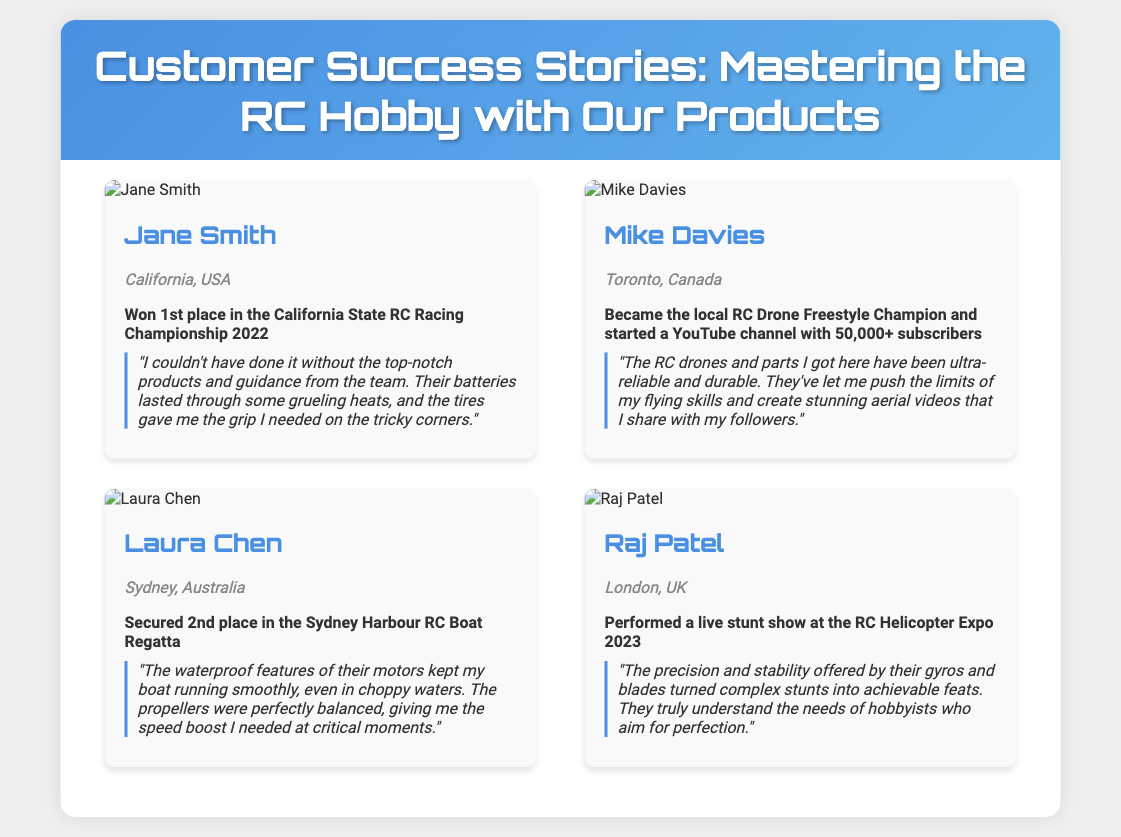What was Jane Smith's achievement in 2022? Jane Smith won 1st place in the California State RC Racing Championship in 2022.
Answer: 1st place in the California State RC Racing Championship 2022 Where is Mike Davies located? Mike Davies is based in Toronto, Canada.
Answer: Toronto, Canada How many subscribers does Mike Davies' YouTube channel have? Mike Davies has 50,000+ subscribers on his YouTube channel.
Answer: 50,000+ What feature of Laura Chen's motors helped in choppy waters? The waterproof features of Laura Chen's motors kept her boat running smoothly even in choppy waters.
Answer: Waterproof features What was Raj Patel's notable achievement in 2023? Raj Patel performed a live stunt show at the RC Helicopter Expo 2023.
Answer: Live stunt show at the RC Helicopter Expo 2023 What specific parts does Mike Davies appreciate for their reliability? Mike Davies appreciates the RC drones and parts for being ultra-reliable and durable.
Answer: RC drones and parts Which location hosted Jane Smith's championship event? The championship event took place in California, USA.
Answer: California, USA What kind of videos does Mike Davies create? Mike Davies creates stunning aerial videos that he shares with his followers.
Answer: Aerial videos 